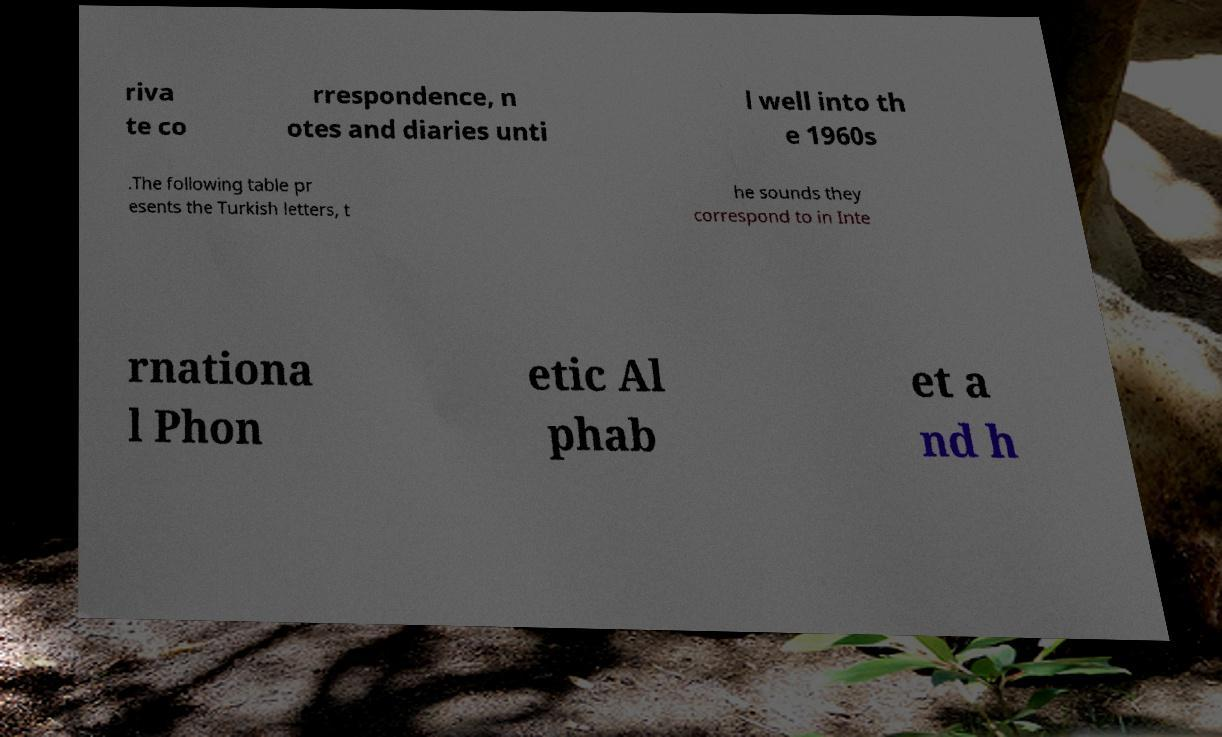There's text embedded in this image that I need extracted. Can you transcribe it verbatim? riva te co rrespondence, n otes and diaries unti l well into th e 1960s .The following table pr esents the Turkish letters, t he sounds they correspond to in Inte rnationa l Phon etic Al phab et a nd h 